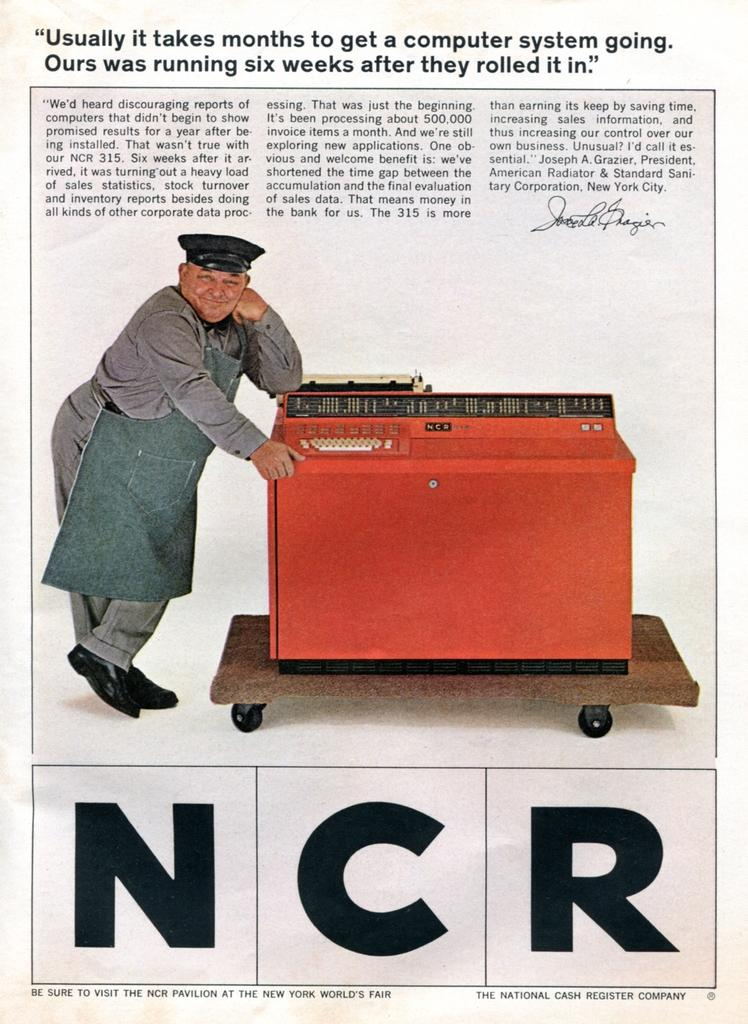What can be seen in the image that people read for news and information? There is a newspaper in the image. Who is present in the image besides the newspaper? A man is standing in the image. What object in the image is used for a specific purpose or function? There is a machine in the image. What is the color of the machine in the image? The machine is red in color. What type of stem can be seen growing from the newspaper in the image? There is no stem growing from the newspaper in the image; it is a printed publication. What type of wool is being spun by the man in the image? There is no man spinning wool in the image; the man is standing near a red machine. 